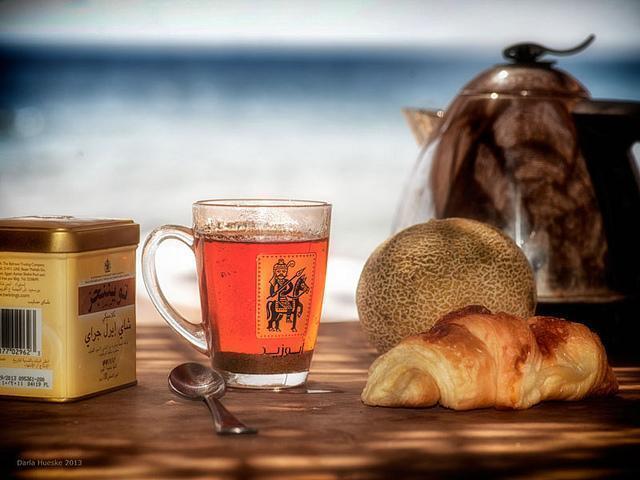What kind of beverage is there on the table top?
Pick the correct solution from the four options below to address the question.
Options: Beer, tea, juice, coffee. Tea. 